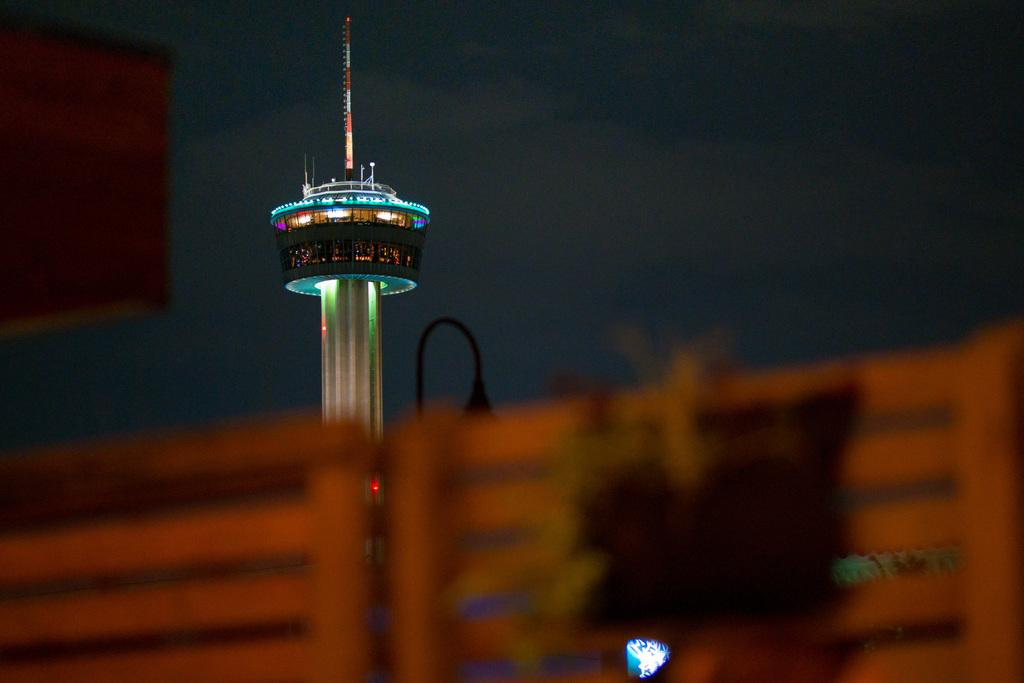What is the main structure in the center of the image? There is a tower in the center of the image. What else can be seen in the image besides the tower? Lights and chairs are visible in the image. Where are the chairs located in the image? The chairs are visible at the bottom of the image. What is visible at the top of the image? The sky is visible at the top of the image. What type of insurance policy is being discussed in the image? There is no discussion of insurance policies in the image; it features a tower, lights, and chairs. How many pins are visible on the tower in the image? There are no pins present on the tower in the image. 